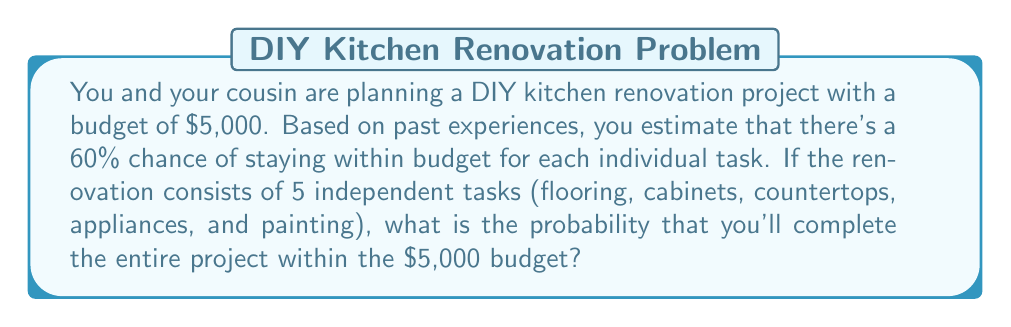Provide a solution to this math problem. Let's approach this step-by-step:

1) For each task, the probability of staying within budget is 60% or 0.6.

2) We need all 5 tasks to stay within budget for the entire project to be within budget.

3) Since the tasks are independent, we can use the multiplication rule of probability.

4) The probability of all 5 tasks staying within budget is:

   $$P(\text{all tasks within budget}) = 0.6 \times 0.6 \times 0.6 \times 0.6 \times 0.6$$

5) This can be written as:

   $$P(\text{all tasks within budget}) = 0.6^5$$

6) Let's calculate this:

   $$0.6^5 = 0.07776$$

7) Converting to a percentage:

   $$0.07776 \times 100\% = 7.776\%$$

Therefore, the probability of completing the entire project within the $5,000 budget is approximately 7.78%.
Answer: $0.07776$ or $7.78\%$ 